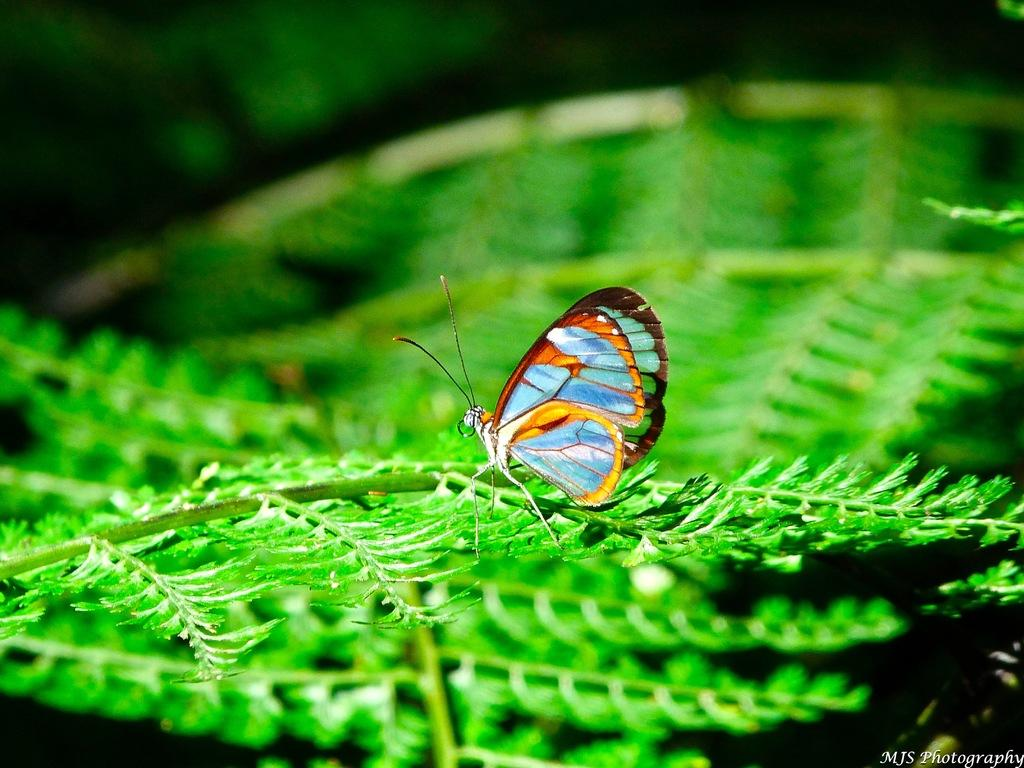What is the main subject of the image? There is a butterfly in the image. Where is the butterfly located? The butterfly is on a leaf. What type of judge is present in the image? There is no judge present in the image; it features a butterfly on a leaf. What type of stew is being prepared in the image? There is no stew being prepared in the image; it features a butterfly on a leaf. 